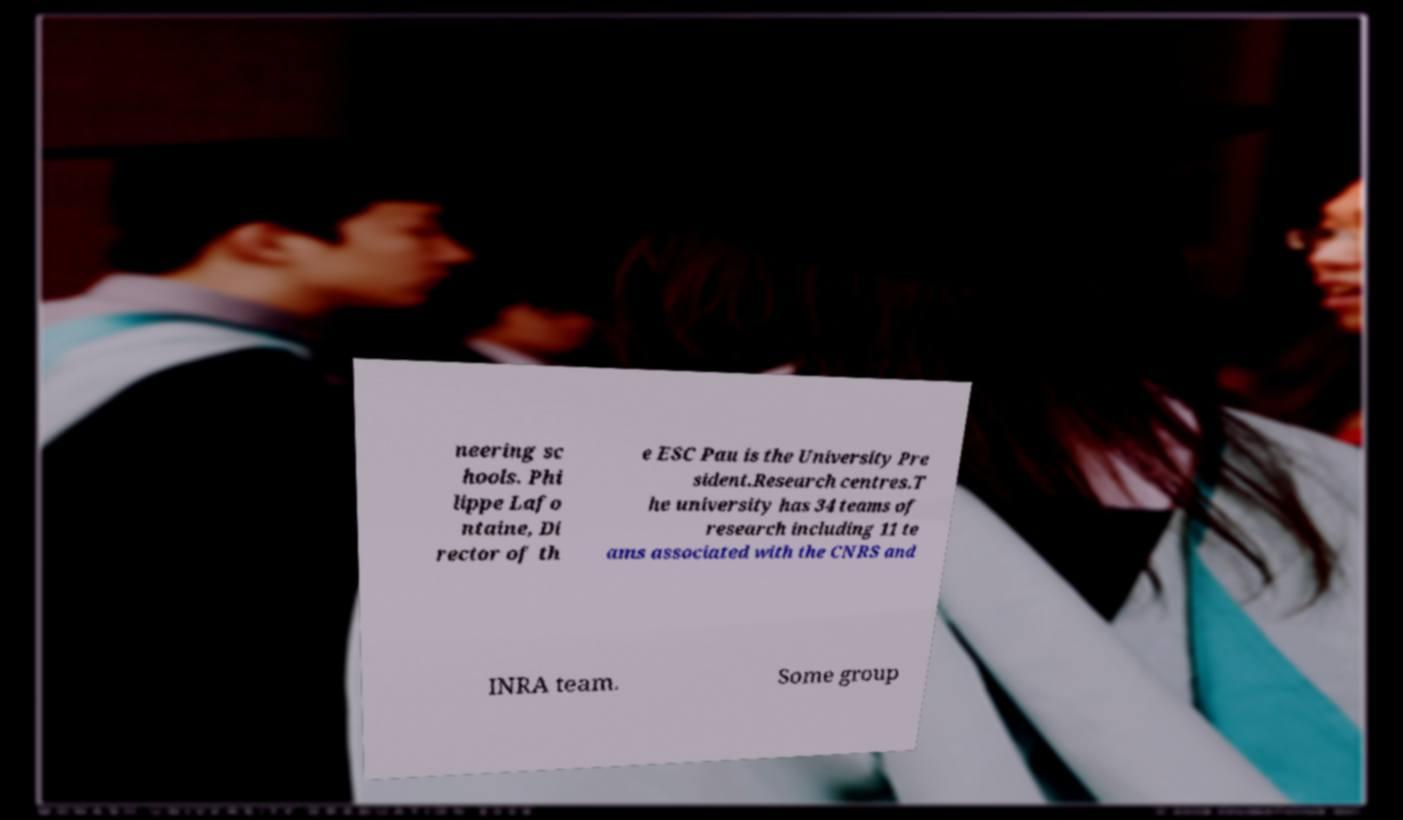Could you assist in decoding the text presented in this image and type it out clearly? neering sc hools. Phi lippe Lafo ntaine, Di rector of th e ESC Pau is the University Pre sident.Research centres.T he university has 34 teams of research including 11 te ams associated with the CNRS and INRA team. Some group 